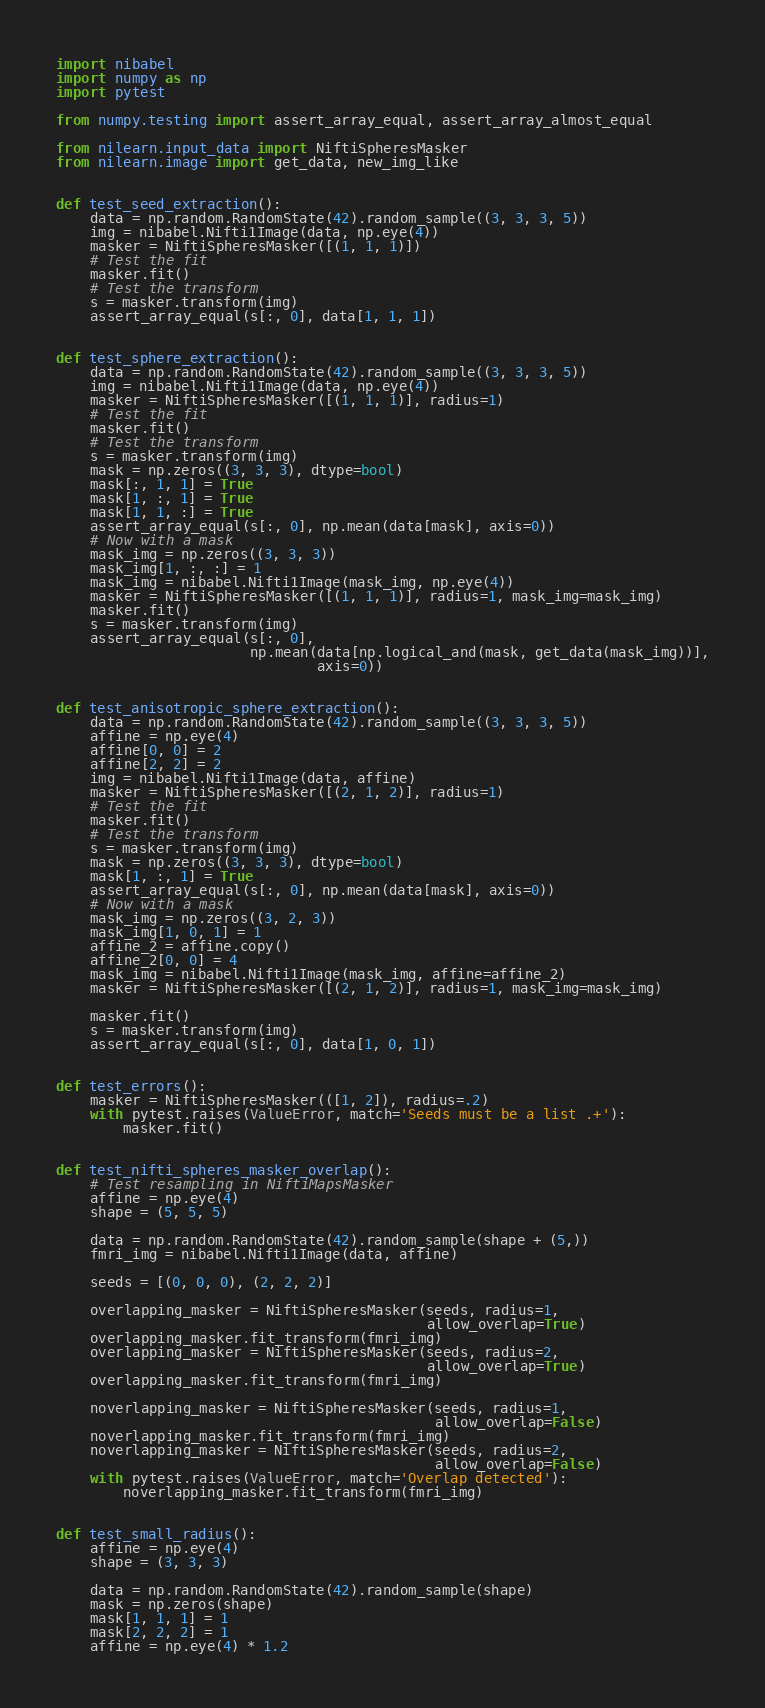<code> <loc_0><loc_0><loc_500><loc_500><_Python_>import nibabel
import numpy as np
import pytest

from numpy.testing import assert_array_equal, assert_array_almost_equal

from nilearn.input_data import NiftiSpheresMasker
from nilearn.image import get_data, new_img_like


def test_seed_extraction():
    data = np.random.RandomState(42).random_sample((3, 3, 3, 5))
    img = nibabel.Nifti1Image(data, np.eye(4))
    masker = NiftiSpheresMasker([(1, 1, 1)])
    # Test the fit
    masker.fit()
    # Test the transform
    s = masker.transform(img)
    assert_array_equal(s[:, 0], data[1, 1, 1])


def test_sphere_extraction():
    data = np.random.RandomState(42).random_sample((3, 3, 3, 5))
    img = nibabel.Nifti1Image(data, np.eye(4))
    masker = NiftiSpheresMasker([(1, 1, 1)], radius=1)
    # Test the fit
    masker.fit()
    # Test the transform
    s = masker.transform(img)
    mask = np.zeros((3, 3, 3), dtype=bool)
    mask[:, 1, 1] = True
    mask[1, :, 1] = True
    mask[1, 1, :] = True
    assert_array_equal(s[:, 0], np.mean(data[mask], axis=0))
    # Now with a mask
    mask_img = np.zeros((3, 3, 3))
    mask_img[1, :, :] = 1
    mask_img = nibabel.Nifti1Image(mask_img, np.eye(4))
    masker = NiftiSpheresMasker([(1, 1, 1)], radius=1, mask_img=mask_img)
    masker.fit()
    s = masker.transform(img)
    assert_array_equal(s[:, 0],
                       np.mean(data[np.logical_and(mask, get_data(mask_img))],
                               axis=0))


def test_anisotropic_sphere_extraction():
    data = np.random.RandomState(42).random_sample((3, 3, 3, 5))
    affine = np.eye(4)
    affine[0, 0] = 2
    affine[2, 2] = 2
    img = nibabel.Nifti1Image(data, affine)
    masker = NiftiSpheresMasker([(2, 1, 2)], radius=1)
    # Test the fit
    masker.fit()
    # Test the transform
    s = masker.transform(img)
    mask = np.zeros((3, 3, 3), dtype=bool)
    mask[1, :, 1] = True
    assert_array_equal(s[:, 0], np.mean(data[mask], axis=0))
    # Now with a mask
    mask_img = np.zeros((3, 2, 3))
    mask_img[1, 0, 1] = 1
    affine_2 = affine.copy()
    affine_2[0, 0] = 4
    mask_img = nibabel.Nifti1Image(mask_img, affine=affine_2)
    masker = NiftiSpheresMasker([(2, 1, 2)], radius=1, mask_img=mask_img)

    masker.fit()
    s = masker.transform(img)
    assert_array_equal(s[:, 0], data[1, 0, 1])


def test_errors():
    masker = NiftiSpheresMasker(([1, 2]), radius=.2)
    with pytest.raises(ValueError, match='Seeds must be a list .+'):
        masker.fit()


def test_nifti_spheres_masker_overlap():
    # Test resampling in NiftiMapsMasker
    affine = np.eye(4)
    shape = (5, 5, 5)

    data = np.random.RandomState(42).random_sample(shape + (5,))
    fmri_img = nibabel.Nifti1Image(data, affine)

    seeds = [(0, 0, 0), (2, 2, 2)]

    overlapping_masker = NiftiSpheresMasker(seeds, radius=1,
                                            allow_overlap=True)
    overlapping_masker.fit_transform(fmri_img)
    overlapping_masker = NiftiSpheresMasker(seeds, radius=2,
                                            allow_overlap=True)
    overlapping_masker.fit_transform(fmri_img)

    noverlapping_masker = NiftiSpheresMasker(seeds, radius=1,
                                             allow_overlap=False)
    noverlapping_masker.fit_transform(fmri_img)
    noverlapping_masker = NiftiSpheresMasker(seeds, radius=2,
                                             allow_overlap=False)
    with pytest.raises(ValueError, match='Overlap detected'):
        noverlapping_masker.fit_transform(fmri_img)


def test_small_radius():
    affine = np.eye(4)
    shape = (3, 3, 3)

    data = np.random.RandomState(42).random_sample(shape)
    mask = np.zeros(shape)
    mask[1, 1, 1] = 1
    mask[2, 2, 2] = 1
    affine = np.eye(4) * 1.2</code> 